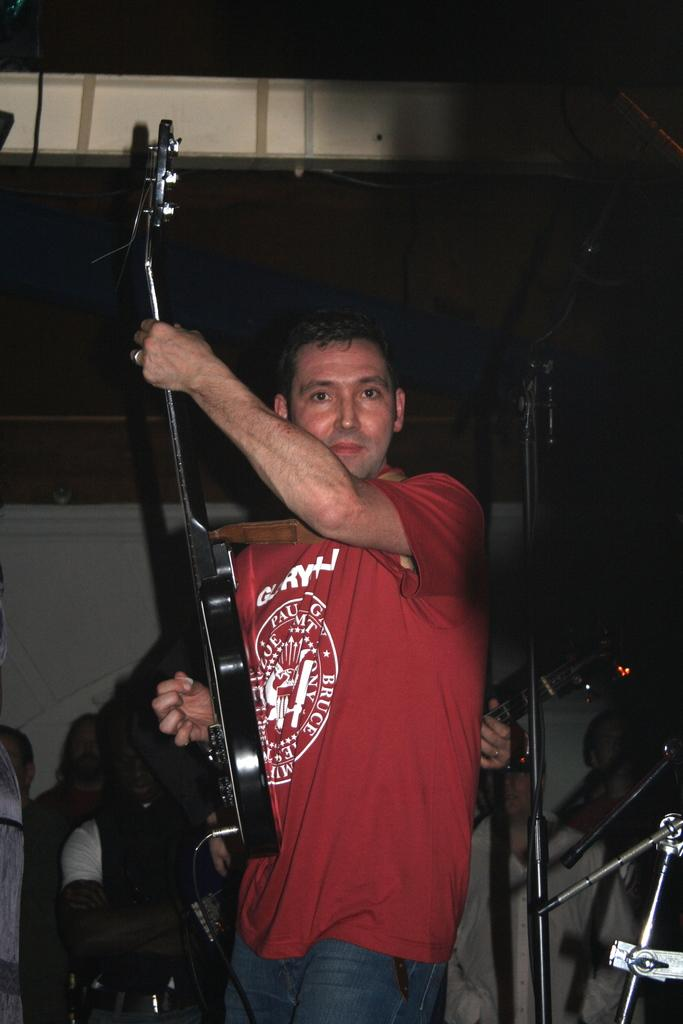What is the man in the image holding? The man is holding a guitar. What can be seen in the background of the image? There are other persons and a building in the background of the image. What type of screw is being used to hold the pencil in the image? There is no screw or pencil present in the image. How many yams are visible in the image? There are no yams present in the image. 